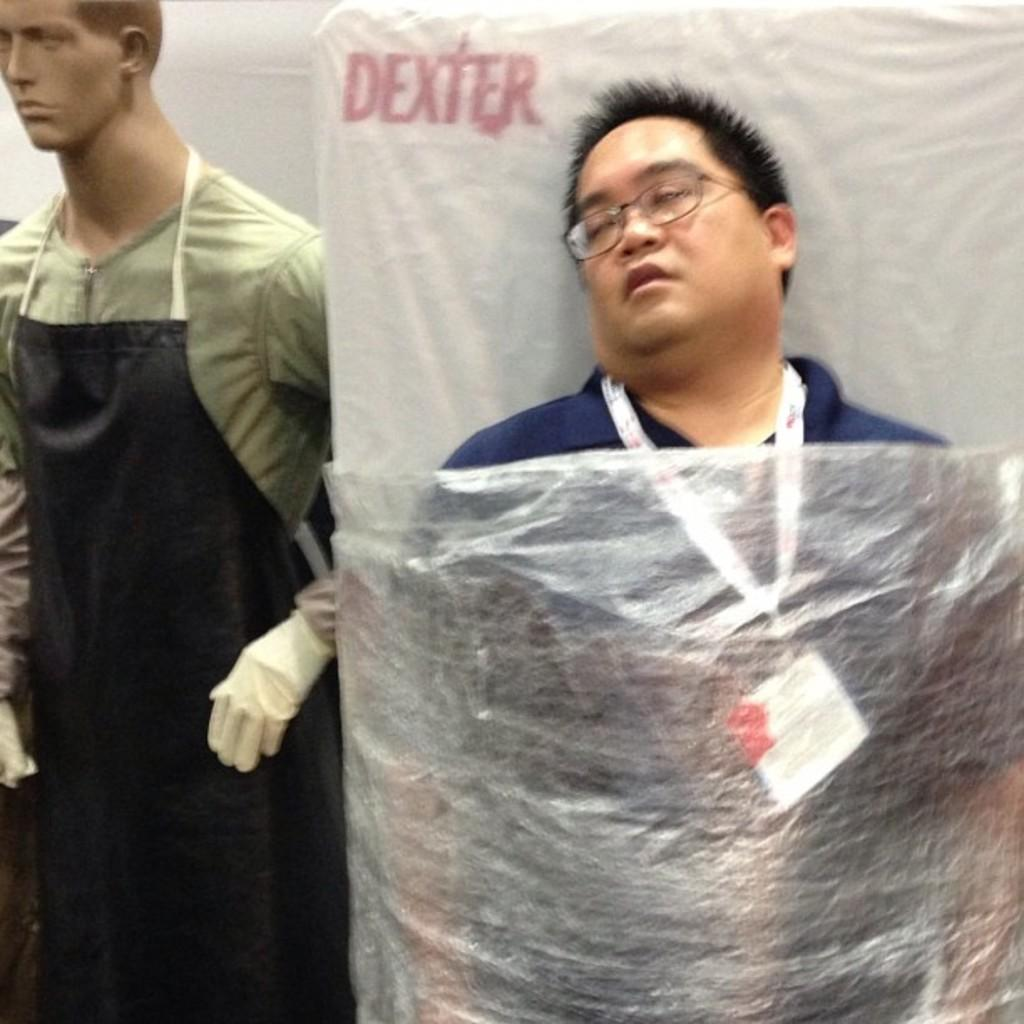Who or what is on the right side of the image? There is a person on the right side of the image. What is the person near in the image? The person is near a bed. What is on the left side of the image? There is a mannequin on the left side of the image. What can be seen in the background of the image? There is a wall in the background of the image. What type of metal structure can be seen in the image? There is no metal structure present in the image. How many spiders are crawling on the wall in the image? There are no spiders visible in the image; only a person, a mannequin, and a wall are present. 